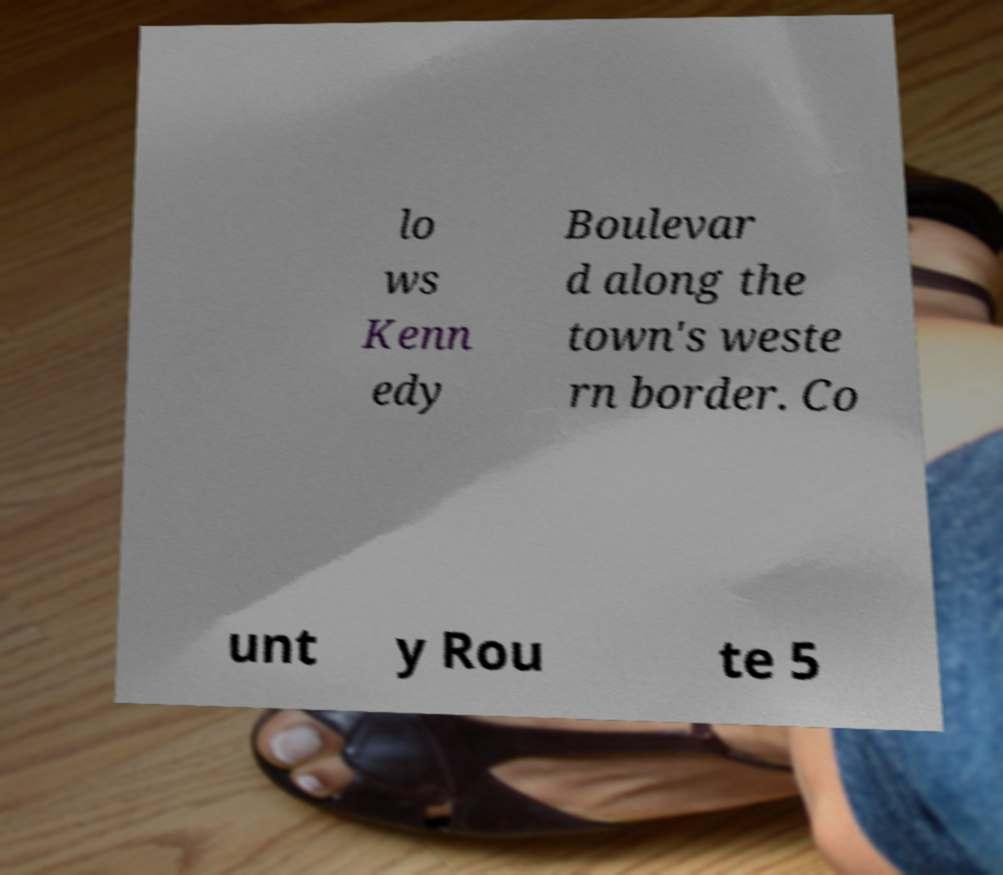Please read and relay the text visible in this image. What does it say? lo ws Kenn edy Boulevar d along the town's weste rn border. Co unt y Rou te 5 